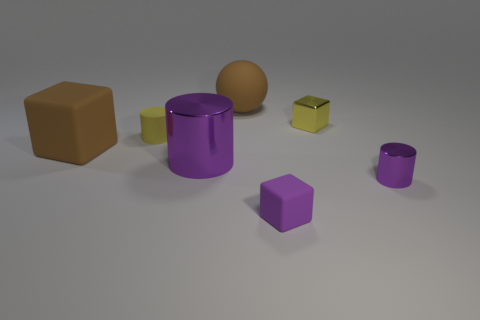Subtract all purple cylinders. How many were subtracted if there are1purple cylinders left? 1 Add 1 gray matte cylinders. How many objects exist? 8 Subtract all blocks. How many objects are left? 4 Add 1 large purple matte objects. How many large purple matte objects exist? 1 Subtract 0 blue blocks. How many objects are left? 7 Subtract all small purple metal things. Subtract all large brown spheres. How many objects are left? 5 Add 6 purple matte cubes. How many purple matte cubes are left? 7 